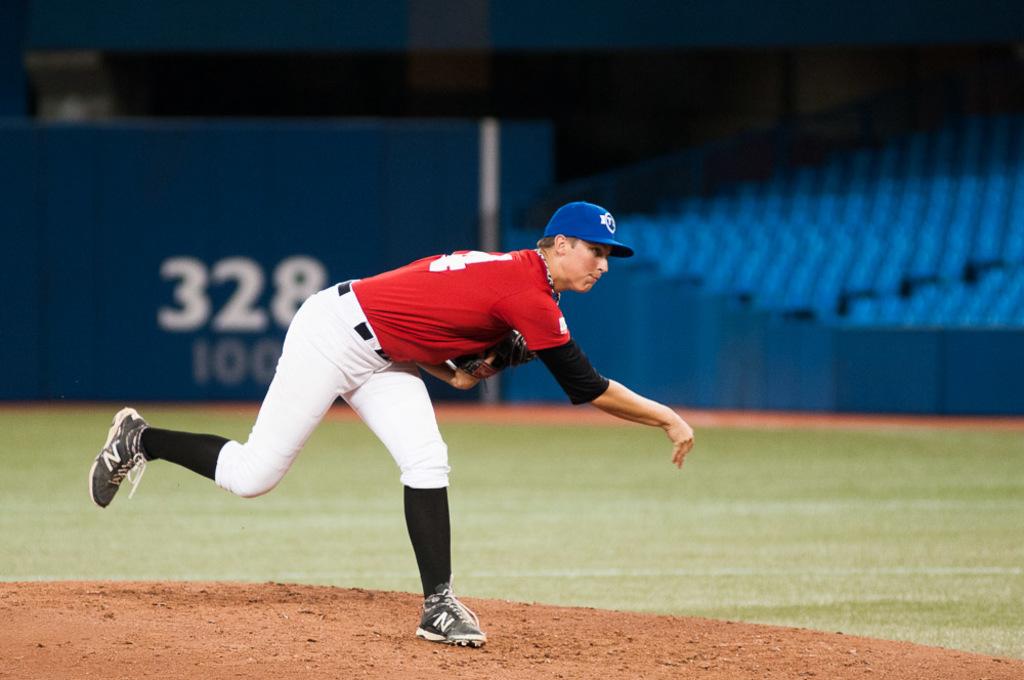What is the number beneath the white number?
Offer a very short reply. 100. 